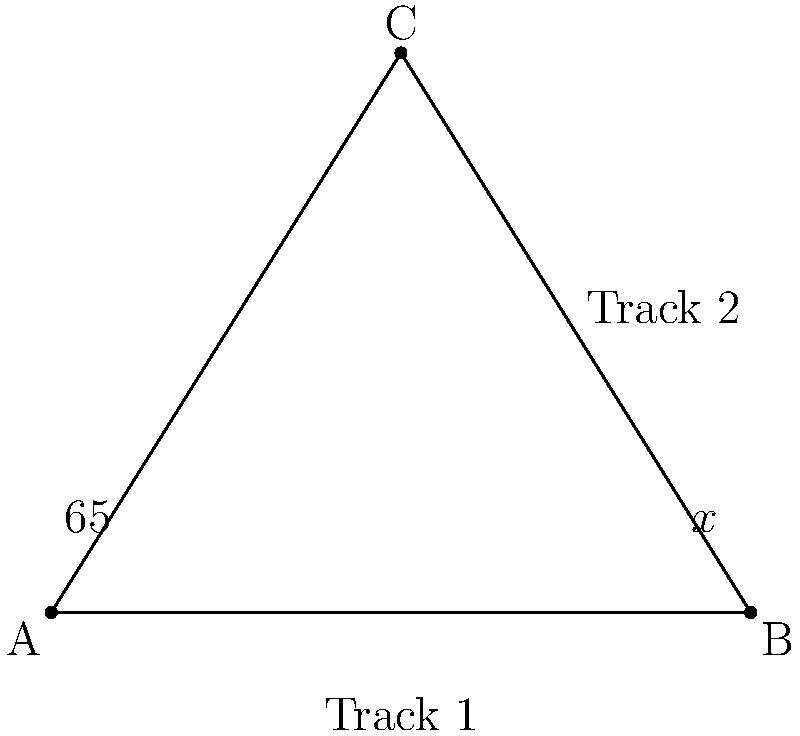During your visit to an Italian rail yard, you notice two railway tracks intersecting at point C. Track 1 forms a 65° angle with the line AC. If triangle ABC is isosceles with AB = BC, what is the measure of angle x formed by Track 2 and line BC? Let's approach this step-by-step:

1) In an isosceles triangle, the base angles are equal. Since AB = BC, angles BAC and BCA are equal.

2) The sum of angles in a triangle is 180°. Let's call the measure of angles BAC and BCA as y°. We can write:
   $$65° + y° + y° = 180°$$
   $$65° + 2y° = 180°$$

3) Solving for y:
   $$2y° = 115°$$
   $$y° = 57.5°$$

4) Now, we know that angle BCA is 57.5°.

5) The angle formed by Track 2 and BC (which we call x°) is supplementary to angle BCA. This means:
   $$x° + 57.5° = 180°$$

6) Solving for x:
   $$x° = 180° - 57.5° = 122.5°$$

Therefore, the measure of angle x is 122.5°.
Answer: 122.5° 